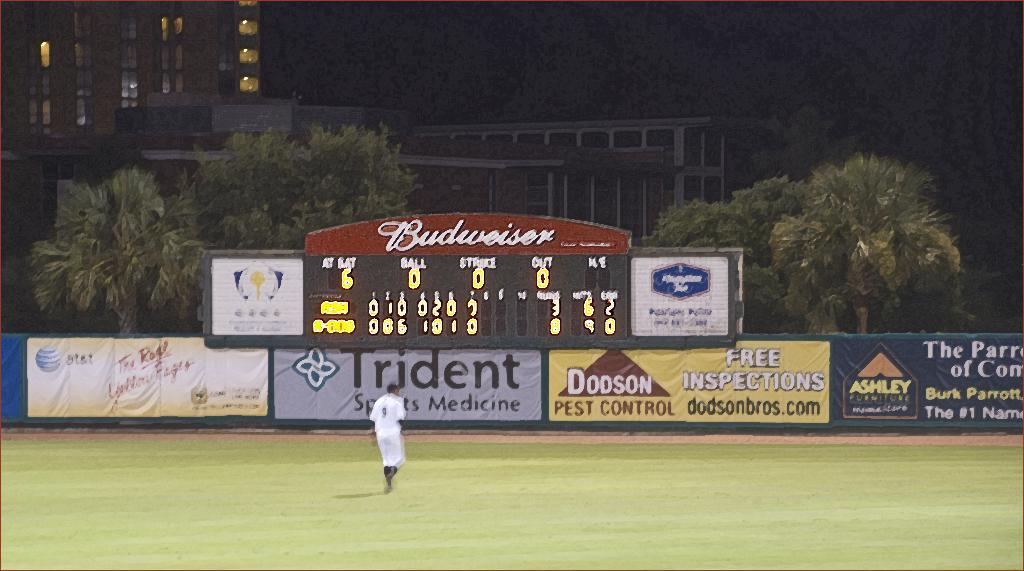What beer is the sponsor on top of the scoreboard?
Give a very brief answer. Budweiser. 